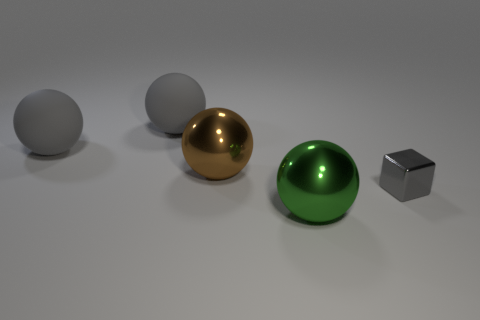Subtract 1 balls. How many balls are left? 3 Subtract all cyan balls. Subtract all purple blocks. How many balls are left? 4 Add 2 small red cubes. How many objects exist? 7 Subtract all blocks. How many objects are left? 4 Add 2 large green spheres. How many large green spheres are left? 3 Add 4 large rubber cylinders. How many large rubber cylinders exist? 4 Subtract 0 brown cylinders. How many objects are left? 5 Subtract all large green metallic balls. Subtract all large brown metal balls. How many objects are left? 3 